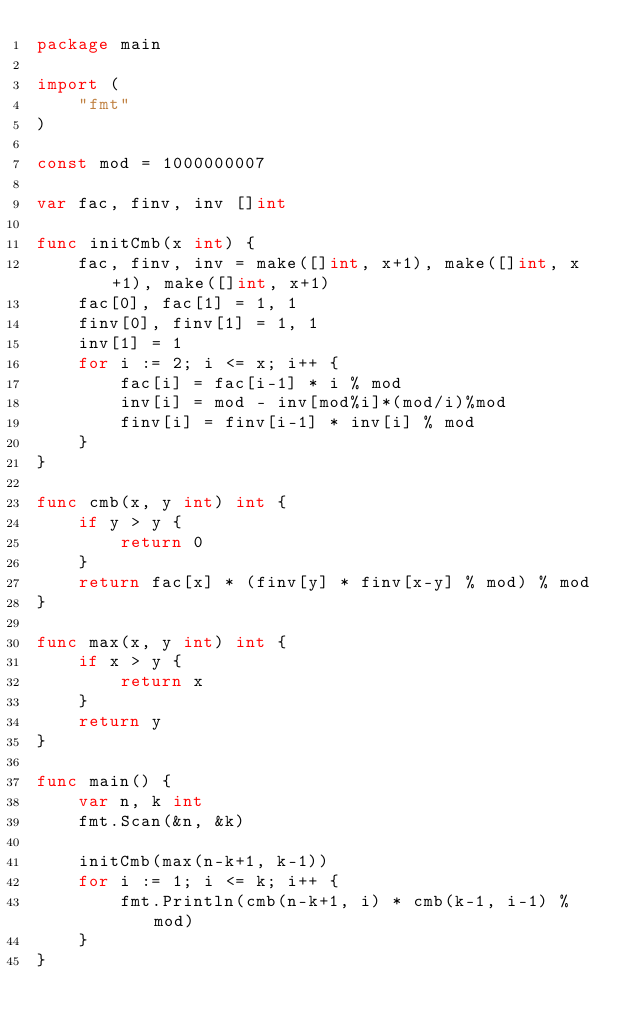Convert code to text. <code><loc_0><loc_0><loc_500><loc_500><_Go_>package main

import (
	"fmt"
)

const mod = 1000000007

var fac, finv, inv []int

func initCmb(x int) {
	fac, finv, inv = make([]int, x+1), make([]int, x+1), make([]int, x+1)
	fac[0], fac[1] = 1, 1
	finv[0], finv[1] = 1, 1
	inv[1] = 1
	for i := 2; i <= x; i++ {
		fac[i] = fac[i-1] * i % mod
		inv[i] = mod - inv[mod%i]*(mod/i)%mod
		finv[i] = finv[i-1] * inv[i] % mod
	}
}

func cmb(x, y int) int {
	if y > y {
		return 0
	}
	return fac[x] * (finv[y] * finv[x-y] % mod) % mod
}

func max(x, y int) int {
	if x > y {
		return x
	}
	return y
}

func main() {
	var n, k int
	fmt.Scan(&n, &k)

	initCmb(max(n-k+1, k-1))
	for i := 1; i <= k; i++ {
		fmt.Println(cmb(n-k+1, i) * cmb(k-1, i-1) % mod)
	}
}
</code> 